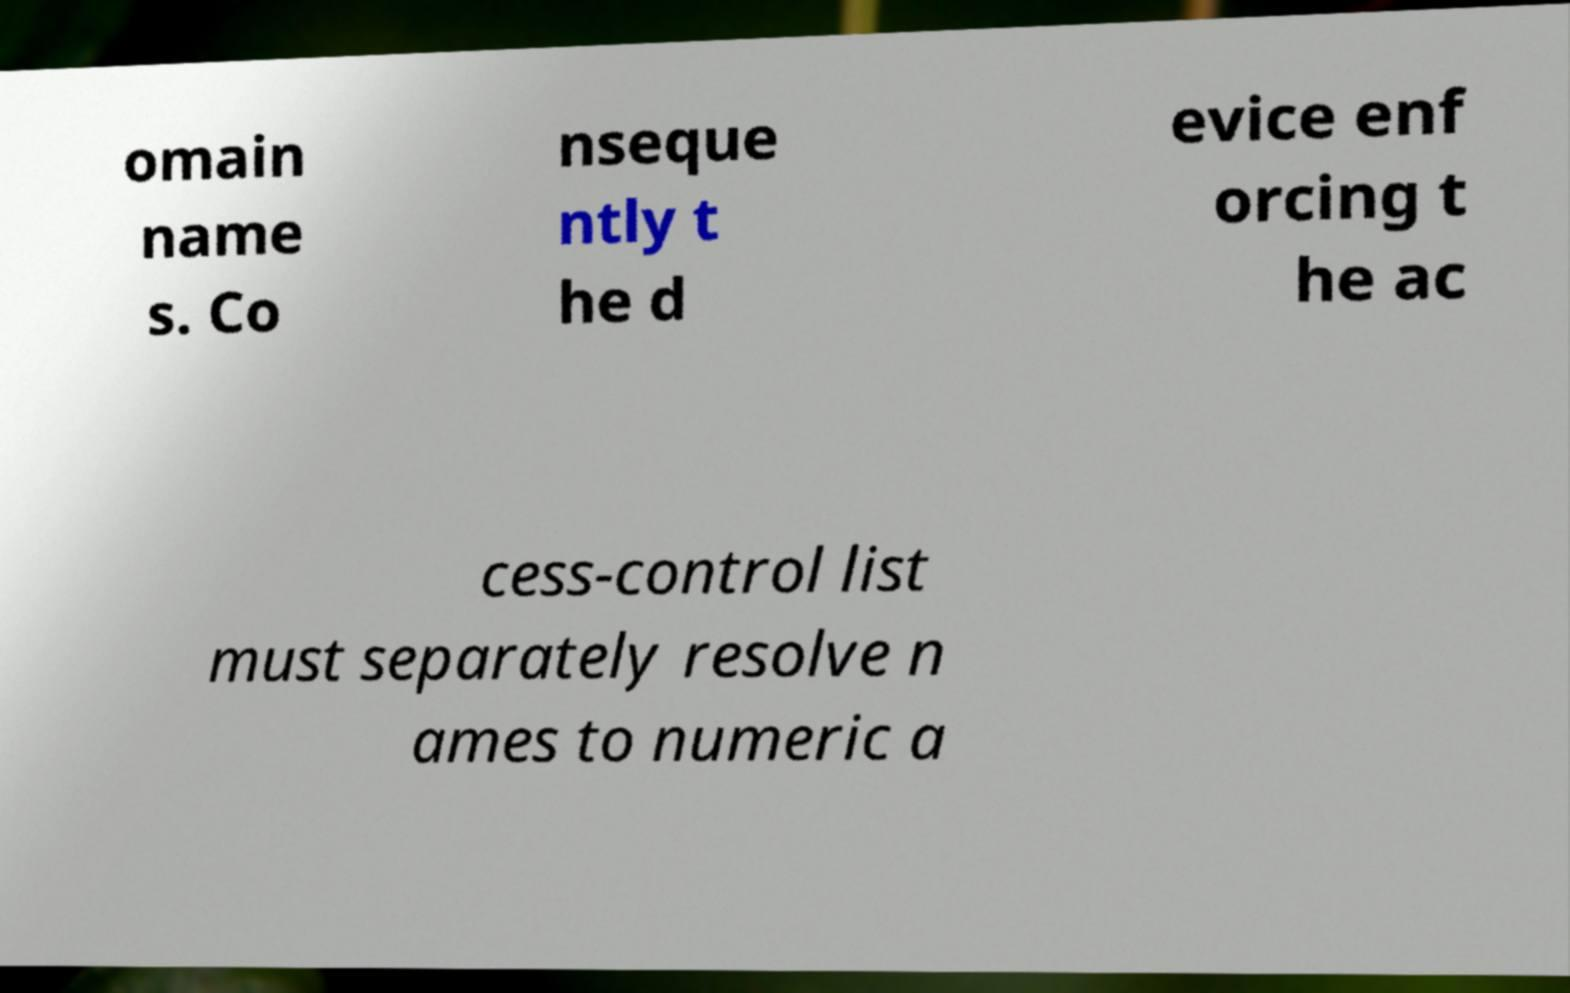Can you read and provide the text displayed in the image?This photo seems to have some interesting text. Can you extract and type it out for me? omain name s. Co nseque ntly t he d evice enf orcing t he ac cess-control list must separately resolve n ames to numeric a 